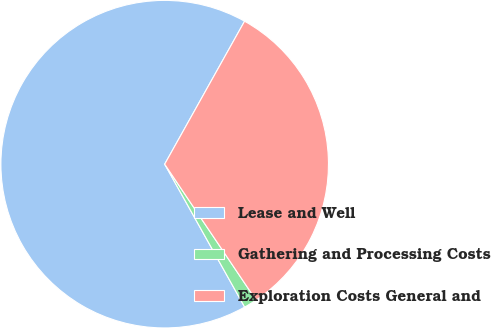Convert chart to OTSL. <chart><loc_0><loc_0><loc_500><loc_500><pie_chart><fcel>Lease and Well<fcel>Gathering and Processing Costs<fcel>Exploration Costs General and<nl><fcel>66.23%<fcel>1.3%<fcel>32.47%<nl></chart> 